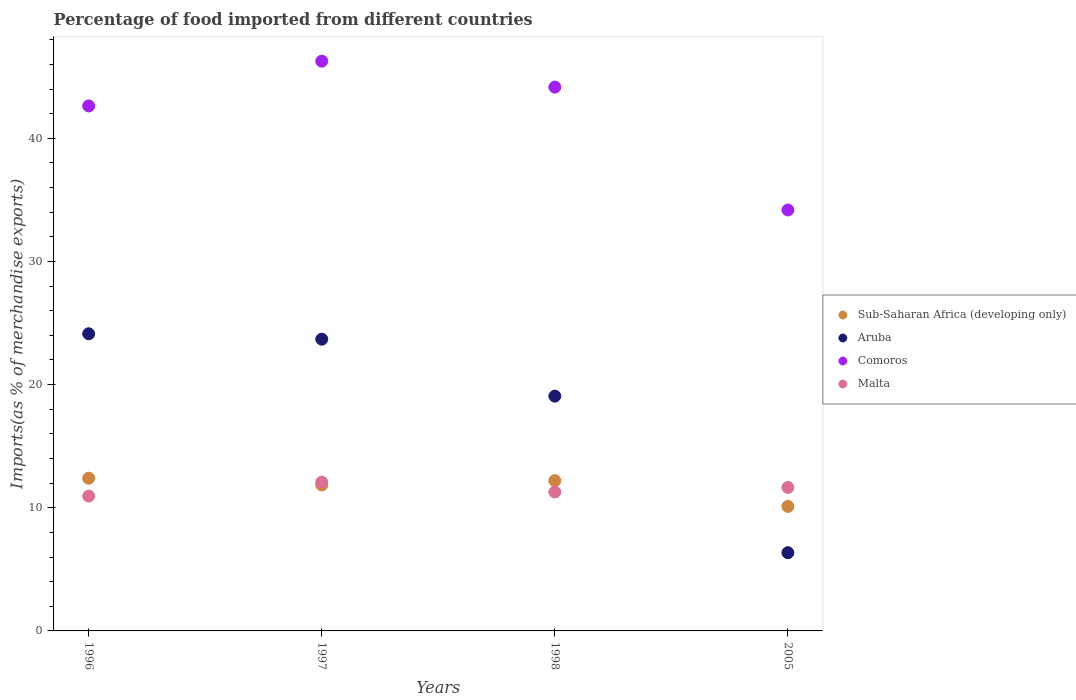How many different coloured dotlines are there?
Offer a very short reply. 4. What is the percentage of imports to different countries in Malta in 2005?
Offer a terse response. 11.65. Across all years, what is the maximum percentage of imports to different countries in Malta?
Offer a terse response. 12.08. Across all years, what is the minimum percentage of imports to different countries in Aruba?
Offer a very short reply. 6.35. In which year was the percentage of imports to different countries in Comoros minimum?
Your answer should be very brief. 2005. What is the total percentage of imports to different countries in Comoros in the graph?
Offer a very short reply. 167.23. What is the difference between the percentage of imports to different countries in Aruba in 1996 and that in 1998?
Your response must be concise. 5.06. What is the difference between the percentage of imports to different countries in Aruba in 1997 and the percentage of imports to different countries in Comoros in 2005?
Ensure brevity in your answer.  -10.49. What is the average percentage of imports to different countries in Comoros per year?
Offer a very short reply. 41.81. In the year 2005, what is the difference between the percentage of imports to different countries in Aruba and percentage of imports to different countries in Malta?
Your answer should be very brief. -5.3. What is the ratio of the percentage of imports to different countries in Malta in 1997 to that in 1998?
Your response must be concise. 1.07. Is the percentage of imports to different countries in Comoros in 1997 less than that in 1998?
Ensure brevity in your answer.  No. What is the difference between the highest and the second highest percentage of imports to different countries in Sub-Saharan Africa (developing only)?
Your answer should be compact. 0.2. What is the difference between the highest and the lowest percentage of imports to different countries in Aruba?
Ensure brevity in your answer.  17.78. Is the sum of the percentage of imports to different countries in Malta in 1997 and 1998 greater than the maximum percentage of imports to different countries in Aruba across all years?
Your response must be concise. No. Is it the case that in every year, the sum of the percentage of imports to different countries in Sub-Saharan Africa (developing only) and percentage of imports to different countries in Aruba  is greater than the sum of percentage of imports to different countries in Malta and percentage of imports to different countries in Comoros?
Keep it short and to the point. No. Is it the case that in every year, the sum of the percentage of imports to different countries in Malta and percentage of imports to different countries in Aruba  is greater than the percentage of imports to different countries in Comoros?
Provide a succinct answer. No. Does the percentage of imports to different countries in Malta monotonically increase over the years?
Your answer should be very brief. No. Is the percentage of imports to different countries in Comoros strictly less than the percentage of imports to different countries in Sub-Saharan Africa (developing only) over the years?
Offer a very short reply. No. How many years are there in the graph?
Ensure brevity in your answer.  4. Are the values on the major ticks of Y-axis written in scientific E-notation?
Make the answer very short. No. Does the graph contain any zero values?
Your answer should be compact. No. Does the graph contain grids?
Your answer should be compact. No. How many legend labels are there?
Your answer should be compact. 4. How are the legend labels stacked?
Offer a terse response. Vertical. What is the title of the graph?
Give a very brief answer. Percentage of food imported from different countries. Does "Tajikistan" appear as one of the legend labels in the graph?
Your answer should be very brief. No. What is the label or title of the X-axis?
Your answer should be very brief. Years. What is the label or title of the Y-axis?
Your answer should be compact. Imports(as % of merchandise exports). What is the Imports(as % of merchandise exports) in Sub-Saharan Africa (developing only) in 1996?
Offer a very short reply. 12.4. What is the Imports(as % of merchandise exports) in Aruba in 1996?
Make the answer very short. 24.13. What is the Imports(as % of merchandise exports) of Comoros in 1996?
Offer a terse response. 42.63. What is the Imports(as % of merchandise exports) of Malta in 1996?
Give a very brief answer. 10.95. What is the Imports(as % of merchandise exports) in Sub-Saharan Africa (developing only) in 1997?
Your answer should be compact. 11.85. What is the Imports(as % of merchandise exports) of Aruba in 1997?
Give a very brief answer. 23.69. What is the Imports(as % of merchandise exports) of Comoros in 1997?
Give a very brief answer. 46.27. What is the Imports(as % of merchandise exports) of Malta in 1997?
Your response must be concise. 12.08. What is the Imports(as % of merchandise exports) in Sub-Saharan Africa (developing only) in 1998?
Your response must be concise. 12.2. What is the Imports(as % of merchandise exports) in Aruba in 1998?
Your response must be concise. 19.06. What is the Imports(as % of merchandise exports) in Comoros in 1998?
Your answer should be compact. 44.16. What is the Imports(as % of merchandise exports) in Malta in 1998?
Keep it short and to the point. 11.28. What is the Imports(as % of merchandise exports) of Sub-Saharan Africa (developing only) in 2005?
Ensure brevity in your answer.  10.11. What is the Imports(as % of merchandise exports) in Aruba in 2005?
Offer a terse response. 6.35. What is the Imports(as % of merchandise exports) of Comoros in 2005?
Give a very brief answer. 34.18. What is the Imports(as % of merchandise exports) in Malta in 2005?
Offer a very short reply. 11.65. Across all years, what is the maximum Imports(as % of merchandise exports) of Sub-Saharan Africa (developing only)?
Make the answer very short. 12.4. Across all years, what is the maximum Imports(as % of merchandise exports) in Aruba?
Your answer should be compact. 24.13. Across all years, what is the maximum Imports(as % of merchandise exports) in Comoros?
Give a very brief answer. 46.27. Across all years, what is the maximum Imports(as % of merchandise exports) in Malta?
Make the answer very short. 12.08. Across all years, what is the minimum Imports(as % of merchandise exports) in Sub-Saharan Africa (developing only)?
Your answer should be very brief. 10.11. Across all years, what is the minimum Imports(as % of merchandise exports) of Aruba?
Your answer should be very brief. 6.35. Across all years, what is the minimum Imports(as % of merchandise exports) of Comoros?
Offer a terse response. 34.18. Across all years, what is the minimum Imports(as % of merchandise exports) in Malta?
Your answer should be very brief. 10.95. What is the total Imports(as % of merchandise exports) in Sub-Saharan Africa (developing only) in the graph?
Provide a succinct answer. 46.56. What is the total Imports(as % of merchandise exports) of Aruba in the graph?
Your response must be concise. 73.23. What is the total Imports(as % of merchandise exports) in Comoros in the graph?
Offer a terse response. 167.23. What is the total Imports(as % of merchandise exports) in Malta in the graph?
Provide a short and direct response. 45.96. What is the difference between the Imports(as % of merchandise exports) in Sub-Saharan Africa (developing only) in 1996 and that in 1997?
Offer a very short reply. 0.55. What is the difference between the Imports(as % of merchandise exports) in Aruba in 1996 and that in 1997?
Make the answer very short. 0.44. What is the difference between the Imports(as % of merchandise exports) of Comoros in 1996 and that in 1997?
Your answer should be very brief. -3.64. What is the difference between the Imports(as % of merchandise exports) of Malta in 1996 and that in 1997?
Your response must be concise. -1.13. What is the difference between the Imports(as % of merchandise exports) in Sub-Saharan Africa (developing only) in 1996 and that in 1998?
Your response must be concise. 0.2. What is the difference between the Imports(as % of merchandise exports) of Aruba in 1996 and that in 1998?
Provide a short and direct response. 5.06. What is the difference between the Imports(as % of merchandise exports) in Comoros in 1996 and that in 1998?
Give a very brief answer. -1.53. What is the difference between the Imports(as % of merchandise exports) of Malta in 1996 and that in 1998?
Your response must be concise. -0.33. What is the difference between the Imports(as % of merchandise exports) of Sub-Saharan Africa (developing only) in 1996 and that in 2005?
Ensure brevity in your answer.  2.29. What is the difference between the Imports(as % of merchandise exports) in Aruba in 1996 and that in 2005?
Provide a succinct answer. 17.78. What is the difference between the Imports(as % of merchandise exports) of Comoros in 1996 and that in 2005?
Keep it short and to the point. 8.45. What is the difference between the Imports(as % of merchandise exports) in Malta in 1996 and that in 2005?
Give a very brief answer. -0.7. What is the difference between the Imports(as % of merchandise exports) of Sub-Saharan Africa (developing only) in 1997 and that in 1998?
Your answer should be compact. -0.35. What is the difference between the Imports(as % of merchandise exports) in Aruba in 1997 and that in 1998?
Give a very brief answer. 4.63. What is the difference between the Imports(as % of merchandise exports) of Comoros in 1997 and that in 1998?
Ensure brevity in your answer.  2.11. What is the difference between the Imports(as % of merchandise exports) in Malta in 1997 and that in 1998?
Your response must be concise. 0.8. What is the difference between the Imports(as % of merchandise exports) of Sub-Saharan Africa (developing only) in 1997 and that in 2005?
Your response must be concise. 1.74. What is the difference between the Imports(as % of merchandise exports) in Aruba in 1997 and that in 2005?
Your response must be concise. 17.34. What is the difference between the Imports(as % of merchandise exports) of Comoros in 1997 and that in 2005?
Keep it short and to the point. 12.09. What is the difference between the Imports(as % of merchandise exports) in Malta in 1997 and that in 2005?
Provide a succinct answer. 0.43. What is the difference between the Imports(as % of merchandise exports) of Sub-Saharan Africa (developing only) in 1998 and that in 2005?
Keep it short and to the point. 2.09. What is the difference between the Imports(as % of merchandise exports) in Aruba in 1998 and that in 2005?
Offer a terse response. 12.71. What is the difference between the Imports(as % of merchandise exports) of Comoros in 1998 and that in 2005?
Your answer should be very brief. 9.98. What is the difference between the Imports(as % of merchandise exports) of Malta in 1998 and that in 2005?
Keep it short and to the point. -0.37. What is the difference between the Imports(as % of merchandise exports) in Sub-Saharan Africa (developing only) in 1996 and the Imports(as % of merchandise exports) in Aruba in 1997?
Offer a terse response. -11.29. What is the difference between the Imports(as % of merchandise exports) in Sub-Saharan Africa (developing only) in 1996 and the Imports(as % of merchandise exports) in Comoros in 1997?
Your response must be concise. -33.86. What is the difference between the Imports(as % of merchandise exports) in Sub-Saharan Africa (developing only) in 1996 and the Imports(as % of merchandise exports) in Malta in 1997?
Give a very brief answer. 0.32. What is the difference between the Imports(as % of merchandise exports) in Aruba in 1996 and the Imports(as % of merchandise exports) in Comoros in 1997?
Your response must be concise. -22.14. What is the difference between the Imports(as % of merchandise exports) in Aruba in 1996 and the Imports(as % of merchandise exports) in Malta in 1997?
Give a very brief answer. 12.05. What is the difference between the Imports(as % of merchandise exports) of Comoros in 1996 and the Imports(as % of merchandise exports) of Malta in 1997?
Make the answer very short. 30.55. What is the difference between the Imports(as % of merchandise exports) of Sub-Saharan Africa (developing only) in 1996 and the Imports(as % of merchandise exports) of Aruba in 1998?
Provide a succinct answer. -6.66. What is the difference between the Imports(as % of merchandise exports) in Sub-Saharan Africa (developing only) in 1996 and the Imports(as % of merchandise exports) in Comoros in 1998?
Keep it short and to the point. -31.76. What is the difference between the Imports(as % of merchandise exports) of Sub-Saharan Africa (developing only) in 1996 and the Imports(as % of merchandise exports) of Malta in 1998?
Give a very brief answer. 1.12. What is the difference between the Imports(as % of merchandise exports) of Aruba in 1996 and the Imports(as % of merchandise exports) of Comoros in 1998?
Your answer should be compact. -20.03. What is the difference between the Imports(as % of merchandise exports) of Aruba in 1996 and the Imports(as % of merchandise exports) of Malta in 1998?
Provide a succinct answer. 12.85. What is the difference between the Imports(as % of merchandise exports) of Comoros in 1996 and the Imports(as % of merchandise exports) of Malta in 1998?
Your answer should be very brief. 31.35. What is the difference between the Imports(as % of merchandise exports) of Sub-Saharan Africa (developing only) in 1996 and the Imports(as % of merchandise exports) of Aruba in 2005?
Provide a short and direct response. 6.05. What is the difference between the Imports(as % of merchandise exports) of Sub-Saharan Africa (developing only) in 1996 and the Imports(as % of merchandise exports) of Comoros in 2005?
Offer a terse response. -21.78. What is the difference between the Imports(as % of merchandise exports) of Sub-Saharan Africa (developing only) in 1996 and the Imports(as % of merchandise exports) of Malta in 2005?
Keep it short and to the point. 0.75. What is the difference between the Imports(as % of merchandise exports) in Aruba in 1996 and the Imports(as % of merchandise exports) in Comoros in 2005?
Make the answer very short. -10.05. What is the difference between the Imports(as % of merchandise exports) of Aruba in 1996 and the Imports(as % of merchandise exports) of Malta in 2005?
Keep it short and to the point. 12.48. What is the difference between the Imports(as % of merchandise exports) in Comoros in 1996 and the Imports(as % of merchandise exports) in Malta in 2005?
Your answer should be compact. 30.98. What is the difference between the Imports(as % of merchandise exports) in Sub-Saharan Africa (developing only) in 1997 and the Imports(as % of merchandise exports) in Aruba in 1998?
Provide a short and direct response. -7.21. What is the difference between the Imports(as % of merchandise exports) of Sub-Saharan Africa (developing only) in 1997 and the Imports(as % of merchandise exports) of Comoros in 1998?
Provide a short and direct response. -32.3. What is the difference between the Imports(as % of merchandise exports) in Sub-Saharan Africa (developing only) in 1997 and the Imports(as % of merchandise exports) in Malta in 1998?
Offer a very short reply. 0.57. What is the difference between the Imports(as % of merchandise exports) of Aruba in 1997 and the Imports(as % of merchandise exports) of Comoros in 1998?
Ensure brevity in your answer.  -20.47. What is the difference between the Imports(as % of merchandise exports) of Aruba in 1997 and the Imports(as % of merchandise exports) of Malta in 1998?
Offer a very short reply. 12.41. What is the difference between the Imports(as % of merchandise exports) of Comoros in 1997 and the Imports(as % of merchandise exports) of Malta in 1998?
Offer a very short reply. 34.99. What is the difference between the Imports(as % of merchandise exports) in Sub-Saharan Africa (developing only) in 1997 and the Imports(as % of merchandise exports) in Aruba in 2005?
Offer a very short reply. 5.5. What is the difference between the Imports(as % of merchandise exports) in Sub-Saharan Africa (developing only) in 1997 and the Imports(as % of merchandise exports) in Comoros in 2005?
Your response must be concise. -22.33. What is the difference between the Imports(as % of merchandise exports) of Sub-Saharan Africa (developing only) in 1997 and the Imports(as % of merchandise exports) of Malta in 2005?
Give a very brief answer. 0.2. What is the difference between the Imports(as % of merchandise exports) of Aruba in 1997 and the Imports(as % of merchandise exports) of Comoros in 2005?
Make the answer very short. -10.49. What is the difference between the Imports(as % of merchandise exports) in Aruba in 1997 and the Imports(as % of merchandise exports) in Malta in 2005?
Make the answer very short. 12.04. What is the difference between the Imports(as % of merchandise exports) in Comoros in 1997 and the Imports(as % of merchandise exports) in Malta in 2005?
Offer a terse response. 34.62. What is the difference between the Imports(as % of merchandise exports) in Sub-Saharan Africa (developing only) in 1998 and the Imports(as % of merchandise exports) in Aruba in 2005?
Keep it short and to the point. 5.85. What is the difference between the Imports(as % of merchandise exports) of Sub-Saharan Africa (developing only) in 1998 and the Imports(as % of merchandise exports) of Comoros in 2005?
Provide a succinct answer. -21.98. What is the difference between the Imports(as % of merchandise exports) in Sub-Saharan Africa (developing only) in 1998 and the Imports(as % of merchandise exports) in Malta in 2005?
Your response must be concise. 0.55. What is the difference between the Imports(as % of merchandise exports) in Aruba in 1998 and the Imports(as % of merchandise exports) in Comoros in 2005?
Provide a succinct answer. -15.12. What is the difference between the Imports(as % of merchandise exports) in Aruba in 1998 and the Imports(as % of merchandise exports) in Malta in 2005?
Offer a terse response. 7.41. What is the difference between the Imports(as % of merchandise exports) in Comoros in 1998 and the Imports(as % of merchandise exports) in Malta in 2005?
Offer a very short reply. 32.51. What is the average Imports(as % of merchandise exports) of Sub-Saharan Africa (developing only) per year?
Ensure brevity in your answer.  11.64. What is the average Imports(as % of merchandise exports) in Aruba per year?
Provide a short and direct response. 18.31. What is the average Imports(as % of merchandise exports) in Comoros per year?
Give a very brief answer. 41.81. What is the average Imports(as % of merchandise exports) of Malta per year?
Offer a terse response. 11.49. In the year 1996, what is the difference between the Imports(as % of merchandise exports) of Sub-Saharan Africa (developing only) and Imports(as % of merchandise exports) of Aruba?
Give a very brief answer. -11.73. In the year 1996, what is the difference between the Imports(as % of merchandise exports) of Sub-Saharan Africa (developing only) and Imports(as % of merchandise exports) of Comoros?
Your answer should be very brief. -30.23. In the year 1996, what is the difference between the Imports(as % of merchandise exports) of Sub-Saharan Africa (developing only) and Imports(as % of merchandise exports) of Malta?
Your answer should be compact. 1.45. In the year 1996, what is the difference between the Imports(as % of merchandise exports) in Aruba and Imports(as % of merchandise exports) in Comoros?
Your answer should be compact. -18.5. In the year 1996, what is the difference between the Imports(as % of merchandise exports) in Aruba and Imports(as % of merchandise exports) in Malta?
Provide a succinct answer. 13.18. In the year 1996, what is the difference between the Imports(as % of merchandise exports) in Comoros and Imports(as % of merchandise exports) in Malta?
Make the answer very short. 31.68. In the year 1997, what is the difference between the Imports(as % of merchandise exports) of Sub-Saharan Africa (developing only) and Imports(as % of merchandise exports) of Aruba?
Ensure brevity in your answer.  -11.84. In the year 1997, what is the difference between the Imports(as % of merchandise exports) in Sub-Saharan Africa (developing only) and Imports(as % of merchandise exports) in Comoros?
Offer a very short reply. -34.41. In the year 1997, what is the difference between the Imports(as % of merchandise exports) in Sub-Saharan Africa (developing only) and Imports(as % of merchandise exports) in Malta?
Keep it short and to the point. -0.23. In the year 1997, what is the difference between the Imports(as % of merchandise exports) of Aruba and Imports(as % of merchandise exports) of Comoros?
Ensure brevity in your answer.  -22.58. In the year 1997, what is the difference between the Imports(as % of merchandise exports) of Aruba and Imports(as % of merchandise exports) of Malta?
Make the answer very short. 11.61. In the year 1997, what is the difference between the Imports(as % of merchandise exports) in Comoros and Imports(as % of merchandise exports) in Malta?
Offer a terse response. 34.18. In the year 1998, what is the difference between the Imports(as % of merchandise exports) in Sub-Saharan Africa (developing only) and Imports(as % of merchandise exports) in Aruba?
Provide a short and direct response. -6.86. In the year 1998, what is the difference between the Imports(as % of merchandise exports) in Sub-Saharan Africa (developing only) and Imports(as % of merchandise exports) in Comoros?
Make the answer very short. -31.96. In the year 1998, what is the difference between the Imports(as % of merchandise exports) of Sub-Saharan Africa (developing only) and Imports(as % of merchandise exports) of Malta?
Ensure brevity in your answer.  0.92. In the year 1998, what is the difference between the Imports(as % of merchandise exports) in Aruba and Imports(as % of merchandise exports) in Comoros?
Your answer should be compact. -25.09. In the year 1998, what is the difference between the Imports(as % of merchandise exports) in Aruba and Imports(as % of merchandise exports) in Malta?
Your answer should be very brief. 7.78. In the year 1998, what is the difference between the Imports(as % of merchandise exports) in Comoros and Imports(as % of merchandise exports) in Malta?
Give a very brief answer. 32.88. In the year 2005, what is the difference between the Imports(as % of merchandise exports) in Sub-Saharan Africa (developing only) and Imports(as % of merchandise exports) in Aruba?
Ensure brevity in your answer.  3.76. In the year 2005, what is the difference between the Imports(as % of merchandise exports) in Sub-Saharan Africa (developing only) and Imports(as % of merchandise exports) in Comoros?
Make the answer very short. -24.07. In the year 2005, what is the difference between the Imports(as % of merchandise exports) of Sub-Saharan Africa (developing only) and Imports(as % of merchandise exports) of Malta?
Your answer should be compact. -1.54. In the year 2005, what is the difference between the Imports(as % of merchandise exports) in Aruba and Imports(as % of merchandise exports) in Comoros?
Give a very brief answer. -27.83. In the year 2005, what is the difference between the Imports(as % of merchandise exports) of Aruba and Imports(as % of merchandise exports) of Malta?
Provide a short and direct response. -5.3. In the year 2005, what is the difference between the Imports(as % of merchandise exports) of Comoros and Imports(as % of merchandise exports) of Malta?
Provide a succinct answer. 22.53. What is the ratio of the Imports(as % of merchandise exports) of Sub-Saharan Africa (developing only) in 1996 to that in 1997?
Offer a terse response. 1.05. What is the ratio of the Imports(as % of merchandise exports) of Aruba in 1996 to that in 1997?
Ensure brevity in your answer.  1.02. What is the ratio of the Imports(as % of merchandise exports) of Comoros in 1996 to that in 1997?
Give a very brief answer. 0.92. What is the ratio of the Imports(as % of merchandise exports) of Malta in 1996 to that in 1997?
Give a very brief answer. 0.91. What is the ratio of the Imports(as % of merchandise exports) of Sub-Saharan Africa (developing only) in 1996 to that in 1998?
Your response must be concise. 1.02. What is the ratio of the Imports(as % of merchandise exports) of Aruba in 1996 to that in 1998?
Offer a very short reply. 1.27. What is the ratio of the Imports(as % of merchandise exports) of Comoros in 1996 to that in 1998?
Ensure brevity in your answer.  0.97. What is the ratio of the Imports(as % of merchandise exports) in Malta in 1996 to that in 1998?
Offer a very short reply. 0.97. What is the ratio of the Imports(as % of merchandise exports) in Sub-Saharan Africa (developing only) in 1996 to that in 2005?
Offer a terse response. 1.23. What is the ratio of the Imports(as % of merchandise exports) in Aruba in 1996 to that in 2005?
Offer a terse response. 3.8. What is the ratio of the Imports(as % of merchandise exports) of Comoros in 1996 to that in 2005?
Provide a succinct answer. 1.25. What is the ratio of the Imports(as % of merchandise exports) in Malta in 1996 to that in 2005?
Make the answer very short. 0.94. What is the ratio of the Imports(as % of merchandise exports) in Sub-Saharan Africa (developing only) in 1997 to that in 1998?
Your response must be concise. 0.97. What is the ratio of the Imports(as % of merchandise exports) of Aruba in 1997 to that in 1998?
Offer a terse response. 1.24. What is the ratio of the Imports(as % of merchandise exports) in Comoros in 1997 to that in 1998?
Keep it short and to the point. 1.05. What is the ratio of the Imports(as % of merchandise exports) in Malta in 1997 to that in 1998?
Keep it short and to the point. 1.07. What is the ratio of the Imports(as % of merchandise exports) of Sub-Saharan Africa (developing only) in 1997 to that in 2005?
Your answer should be very brief. 1.17. What is the ratio of the Imports(as % of merchandise exports) in Aruba in 1997 to that in 2005?
Your answer should be very brief. 3.73. What is the ratio of the Imports(as % of merchandise exports) of Comoros in 1997 to that in 2005?
Keep it short and to the point. 1.35. What is the ratio of the Imports(as % of merchandise exports) of Sub-Saharan Africa (developing only) in 1998 to that in 2005?
Your answer should be very brief. 1.21. What is the ratio of the Imports(as % of merchandise exports) in Aruba in 1998 to that in 2005?
Give a very brief answer. 3. What is the ratio of the Imports(as % of merchandise exports) in Comoros in 1998 to that in 2005?
Offer a terse response. 1.29. What is the ratio of the Imports(as % of merchandise exports) in Malta in 1998 to that in 2005?
Ensure brevity in your answer.  0.97. What is the difference between the highest and the second highest Imports(as % of merchandise exports) in Sub-Saharan Africa (developing only)?
Your response must be concise. 0.2. What is the difference between the highest and the second highest Imports(as % of merchandise exports) in Aruba?
Your answer should be very brief. 0.44. What is the difference between the highest and the second highest Imports(as % of merchandise exports) of Comoros?
Provide a short and direct response. 2.11. What is the difference between the highest and the second highest Imports(as % of merchandise exports) in Malta?
Offer a very short reply. 0.43. What is the difference between the highest and the lowest Imports(as % of merchandise exports) of Sub-Saharan Africa (developing only)?
Provide a short and direct response. 2.29. What is the difference between the highest and the lowest Imports(as % of merchandise exports) of Aruba?
Your response must be concise. 17.78. What is the difference between the highest and the lowest Imports(as % of merchandise exports) in Comoros?
Your answer should be compact. 12.09. What is the difference between the highest and the lowest Imports(as % of merchandise exports) in Malta?
Your answer should be very brief. 1.13. 